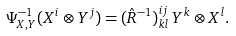Convert formula to latex. <formula><loc_0><loc_0><loc_500><loc_500>\Psi _ { X , Y } ^ { - 1 } ( X ^ { i } \otimes Y ^ { j } ) = ( \hat { R } ^ { - 1 } ) _ { k l } ^ { i j } \, Y ^ { k } \otimes X ^ { l } .</formula> 